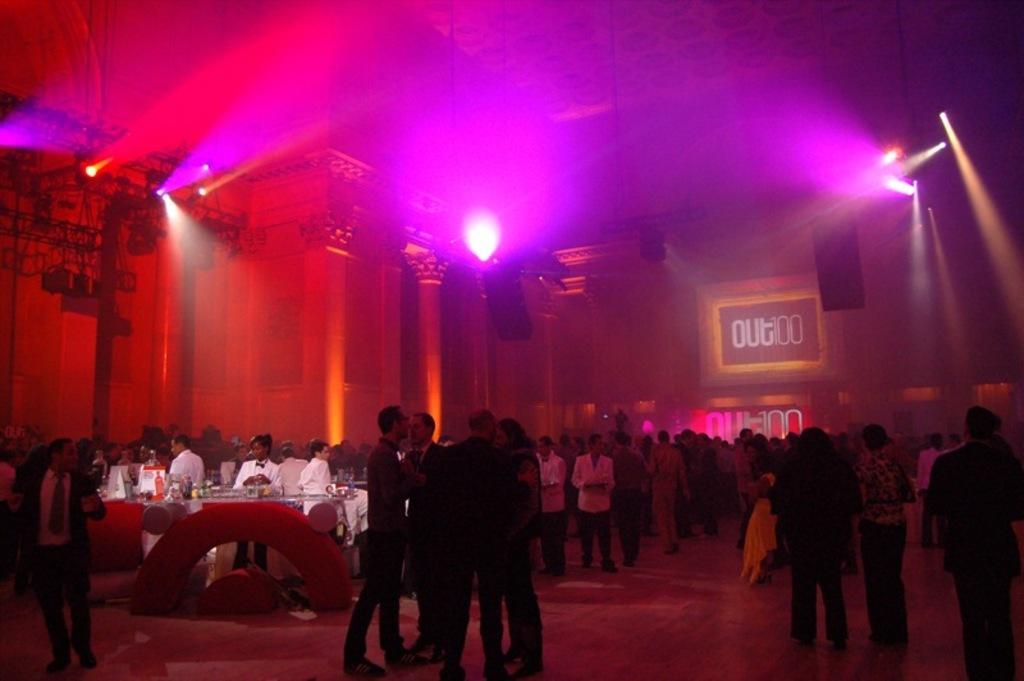How would you summarize this image in a sentence or two? In the image in the center we can see group of people were standing. And we can see one table. On the table,we can see bottles,tissue papers,glasses and few other objects. In the background there is a building,wall,roof,pole,lights,pillars,chairs and few other objects. 